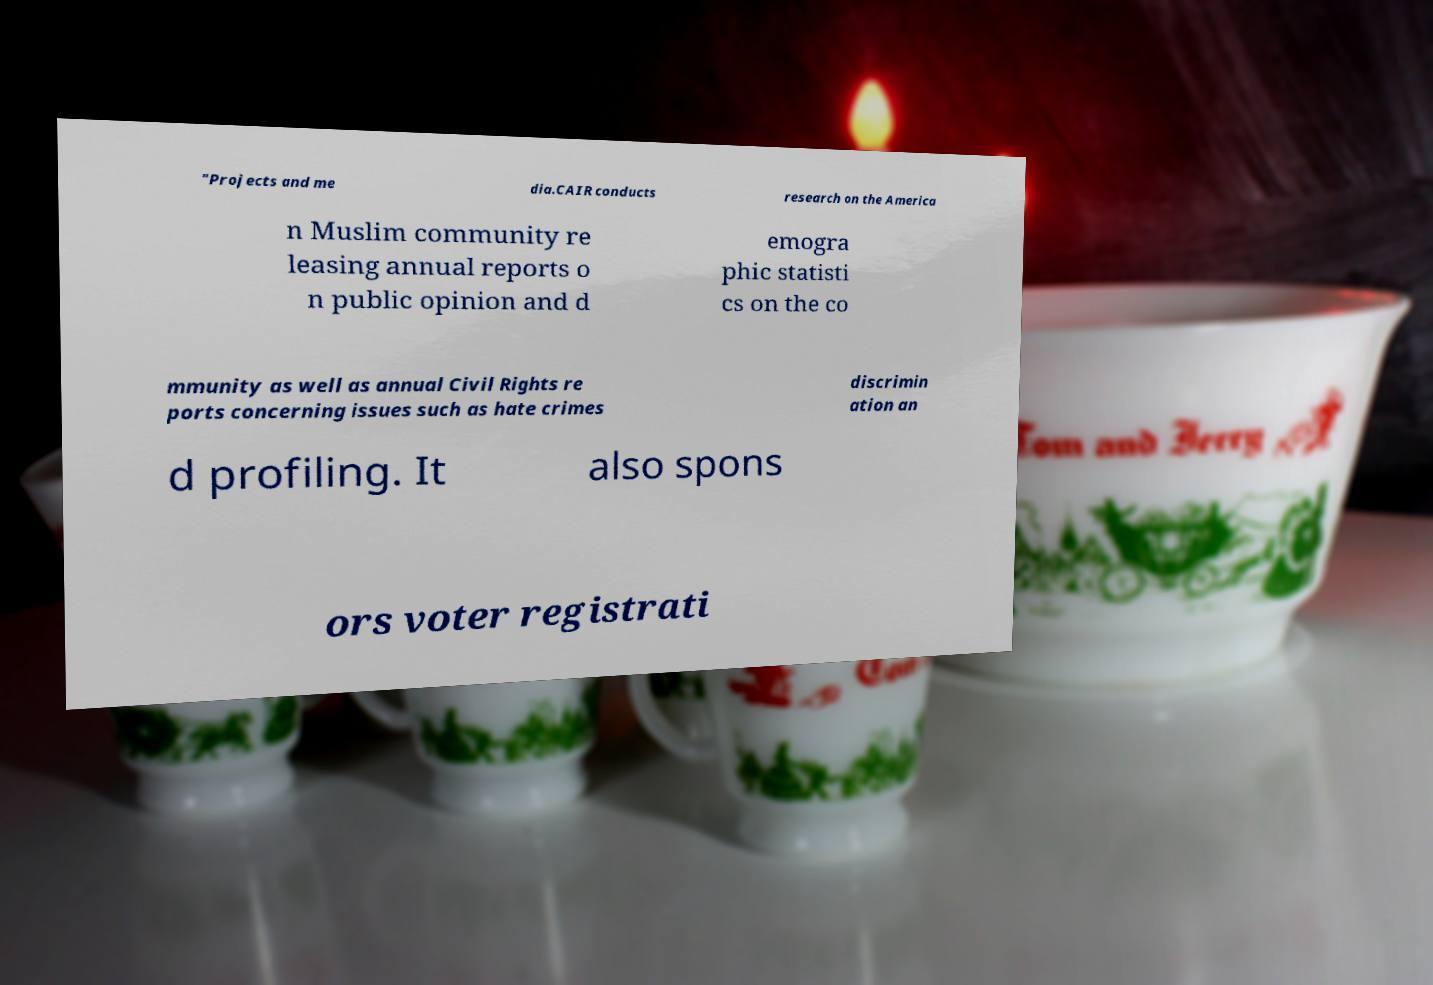What messages or text are displayed in this image? I need them in a readable, typed format. "Projects and me dia.CAIR conducts research on the America n Muslim community re leasing annual reports o n public opinion and d emogra phic statisti cs on the co mmunity as well as annual Civil Rights re ports concerning issues such as hate crimes discrimin ation an d profiling. It also spons ors voter registrati 